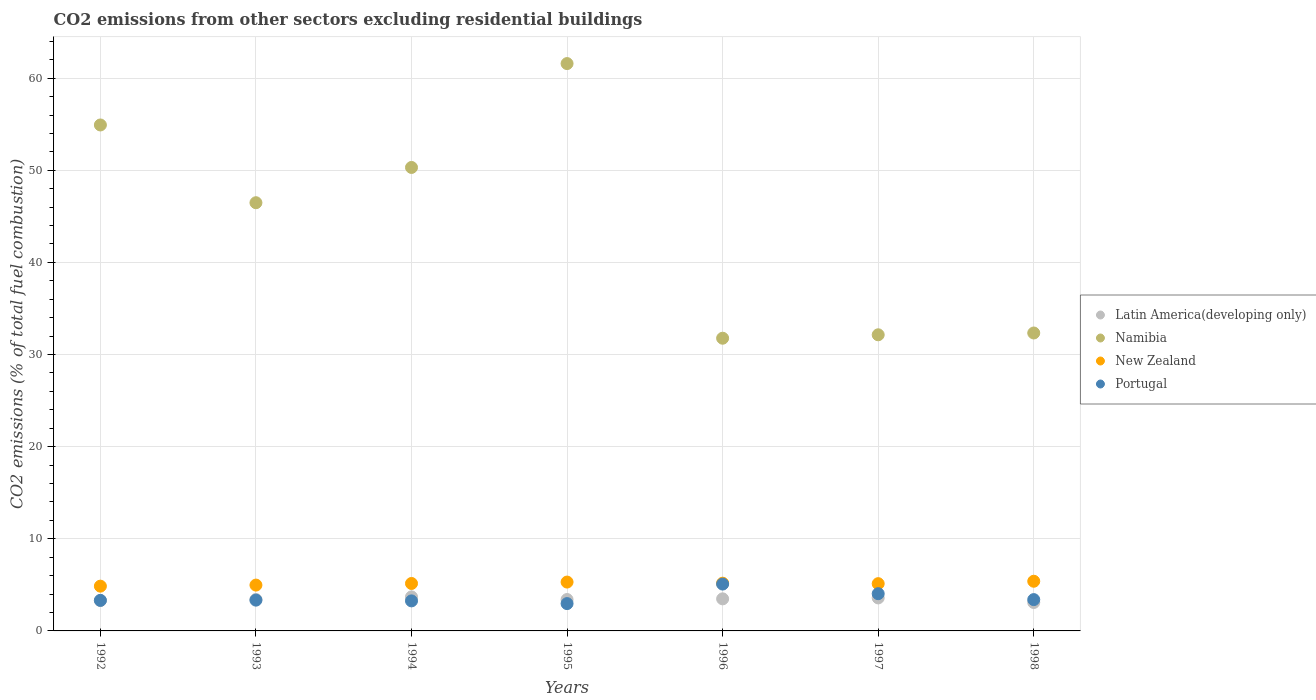Is the number of dotlines equal to the number of legend labels?
Provide a short and direct response. Yes. What is the total CO2 emitted in Portugal in 1998?
Your answer should be very brief. 3.4. Across all years, what is the maximum total CO2 emitted in New Zealand?
Make the answer very short. 5.39. Across all years, what is the minimum total CO2 emitted in Namibia?
Your response must be concise. 31.77. In which year was the total CO2 emitted in Latin America(developing only) maximum?
Offer a very short reply. 1994. What is the total total CO2 emitted in Latin America(developing only) in the graph?
Make the answer very short. 23.96. What is the difference between the total CO2 emitted in Namibia in 1997 and that in 1998?
Make the answer very short. -0.2. What is the difference between the total CO2 emitted in Namibia in 1997 and the total CO2 emitted in Portugal in 1996?
Keep it short and to the point. 27.06. What is the average total CO2 emitted in New Zealand per year?
Give a very brief answer. 5.14. In the year 1996, what is the difference between the total CO2 emitted in Portugal and total CO2 emitted in Namibia?
Make the answer very short. -26.68. What is the ratio of the total CO2 emitted in Latin America(developing only) in 1992 to that in 1998?
Your response must be concise. 1.07. Is the total CO2 emitted in Latin America(developing only) in 1995 less than that in 1998?
Give a very brief answer. No. What is the difference between the highest and the second highest total CO2 emitted in Portugal?
Your answer should be compact. 1.04. What is the difference between the highest and the lowest total CO2 emitted in Latin America(developing only)?
Offer a terse response. 0.61. Is the sum of the total CO2 emitted in Latin America(developing only) in 1993 and 1994 greater than the maximum total CO2 emitted in Namibia across all years?
Provide a short and direct response. No. Is it the case that in every year, the sum of the total CO2 emitted in Latin America(developing only) and total CO2 emitted in Namibia  is greater than the total CO2 emitted in Portugal?
Offer a very short reply. Yes. Is the total CO2 emitted in New Zealand strictly greater than the total CO2 emitted in Namibia over the years?
Provide a short and direct response. No. Is the total CO2 emitted in Latin America(developing only) strictly less than the total CO2 emitted in Namibia over the years?
Your answer should be compact. Yes. How many dotlines are there?
Your answer should be very brief. 4. What is the difference between two consecutive major ticks on the Y-axis?
Offer a terse response. 10. Does the graph contain any zero values?
Make the answer very short. No. What is the title of the graph?
Give a very brief answer. CO2 emissions from other sectors excluding residential buildings. Does "Albania" appear as one of the legend labels in the graph?
Provide a succinct answer. No. What is the label or title of the X-axis?
Offer a terse response. Years. What is the label or title of the Y-axis?
Your answer should be very brief. CO2 emissions (% of total fuel combustion). What is the CO2 emissions (% of total fuel combustion) in Latin America(developing only) in 1992?
Ensure brevity in your answer.  3.3. What is the CO2 emissions (% of total fuel combustion) of Namibia in 1992?
Ensure brevity in your answer.  54.92. What is the CO2 emissions (% of total fuel combustion) of New Zealand in 1992?
Make the answer very short. 4.86. What is the CO2 emissions (% of total fuel combustion) in Portugal in 1992?
Your answer should be very brief. 3.32. What is the CO2 emissions (% of total fuel combustion) in Latin America(developing only) in 1993?
Your response must be concise. 3.41. What is the CO2 emissions (% of total fuel combustion) in Namibia in 1993?
Give a very brief answer. 46.48. What is the CO2 emissions (% of total fuel combustion) in New Zealand in 1993?
Keep it short and to the point. 4.98. What is the CO2 emissions (% of total fuel combustion) in Portugal in 1993?
Make the answer very short. 3.34. What is the CO2 emissions (% of total fuel combustion) of Latin America(developing only) in 1994?
Your answer should be very brief. 3.69. What is the CO2 emissions (% of total fuel combustion) in Namibia in 1994?
Offer a very short reply. 50.31. What is the CO2 emissions (% of total fuel combustion) of New Zealand in 1994?
Provide a short and direct response. 5.15. What is the CO2 emissions (% of total fuel combustion) of Portugal in 1994?
Your response must be concise. 3.26. What is the CO2 emissions (% of total fuel combustion) in Latin America(developing only) in 1995?
Offer a very short reply. 3.41. What is the CO2 emissions (% of total fuel combustion) in Namibia in 1995?
Your answer should be compact. 61.58. What is the CO2 emissions (% of total fuel combustion) of New Zealand in 1995?
Offer a very short reply. 5.3. What is the CO2 emissions (% of total fuel combustion) of Portugal in 1995?
Your answer should be compact. 2.97. What is the CO2 emissions (% of total fuel combustion) in Latin America(developing only) in 1996?
Your answer should be very brief. 3.48. What is the CO2 emissions (% of total fuel combustion) in Namibia in 1996?
Offer a very short reply. 31.77. What is the CO2 emissions (% of total fuel combustion) in New Zealand in 1996?
Ensure brevity in your answer.  5.18. What is the CO2 emissions (% of total fuel combustion) of Portugal in 1996?
Your answer should be very brief. 5.09. What is the CO2 emissions (% of total fuel combustion) of Latin America(developing only) in 1997?
Offer a terse response. 3.58. What is the CO2 emissions (% of total fuel combustion) in Namibia in 1997?
Give a very brief answer. 32.14. What is the CO2 emissions (% of total fuel combustion) in New Zealand in 1997?
Provide a succinct answer. 5.13. What is the CO2 emissions (% of total fuel combustion) in Portugal in 1997?
Offer a very short reply. 4.04. What is the CO2 emissions (% of total fuel combustion) in Latin America(developing only) in 1998?
Provide a short and direct response. 3.09. What is the CO2 emissions (% of total fuel combustion) in Namibia in 1998?
Keep it short and to the point. 32.34. What is the CO2 emissions (% of total fuel combustion) of New Zealand in 1998?
Keep it short and to the point. 5.39. What is the CO2 emissions (% of total fuel combustion) in Portugal in 1998?
Your answer should be very brief. 3.4. Across all years, what is the maximum CO2 emissions (% of total fuel combustion) of Latin America(developing only)?
Ensure brevity in your answer.  3.69. Across all years, what is the maximum CO2 emissions (% of total fuel combustion) of Namibia?
Make the answer very short. 61.58. Across all years, what is the maximum CO2 emissions (% of total fuel combustion) of New Zealand?
Offer a very short reply. 5.39. Across all years, what is the maximum CO2 emissions (% of total fuel combustion) in Portugal?
Offer a very short reply. 5.09. Across all years, what is the minimum CO2 emissions (% of total fuel combustion) in Latin America(developing only)?
Your response must be concise. 3.09. Across all years, what is the minimum CO2 emissions (% of total fuel combustion) of Namibia?
Your answer should be compact. 31.77. Across all years, what is the minimum CO2 emissions (% of total fuel combustion) of New Zealand?
Keep it short and to the point. 4.86. Across all years, what is the minimum CO2 emissions (% of total fuel combustion) of Portugal?
Provide a succinct answer. 2.97. What is the total CO2 emissions (% of total fuel combustion) in Latin America(developing only) in the graph?
Ensure brevity in your answer.  23.96. What is the total CO2 emissions (% of total fuel combustion) in Namibia in the graph?
Offer a very short reply. 309.54. What is the total CO2 emissions (% of total fuel combustion) of New Zealand in the graph?
Ensure brevity in your answer.  35.99. What is the total CO2 emissions (% of total fuel combustion) of Portugal in the graph?
Your answer should be very brief. 25.41. What is the difference between the CO2 emissions (% of total fuel combustion) of Latin America(developing only) in 1992 and that in 1993?
Give a very brief answer. -0.11. What is the difference between the CO2 emissions (% of total fuel combustion) of Namibia in 1992 and that in 1993?
Your response must be concise. 8.44. What is the difference between the CO2 emissions (% of total fuel combustion) of New Zealand in 1992 and that in 1993?
Provide a succinct answer. -0.12. What is the difference between the CO2 emissions (% of total fuel combustion) of Portugal in 1992 and that in 1993?
Your response must be concise. -0.02. What is the difference between the CO2 emissions (% of total fuel combustion) of Latin America(developing only) in 1992 and that in 1994?
Give a very brief answer. -0.39. What is the difference between the CO2 emissions (% of total fuel combustion) of Namibia in 1992 and that in 1994?
Your answer should be compact. 4.61. What is the difference between the CO2 emissions (% of total fuel combustion) of New Zealand in 1992 and that in 1994?
Provide a succinct answer. -0.29. What is the difference between the CO2 emissions (% of total fuel combustion) in Portugal in 1992 and that in 1994?
Your answer should be very brief. 0.06. What is the difference between the CO2 emissions (% of total fuel combustion) of Latin America(developing only) in 1992 and that in 1995?
Make the answer very short. -0.11. What is the difference between the CO2 emissions (% of total fuel combustion) of Namibia in 1992 and that in 1995?
Offer a terse response. -6.66. What is the difference between the CO2 emissions (% of total fuel combustion) of New Zealand in 1992 and that in 1995?
Provide a succinct answer. -0.44. What is the difference between the CO2 emissions (% of total fuel combustion) in Portugal in 1992 and that in 1995?
Offer a terse response. 0.35. What is the difference between the CO2 emissions (% of total fuel combustion) of Latin America(developing only) in 1992 and that in 1996?
Your response must be concise. -0.18. What is the difference between the CO2 emissions (% of total fuel combustion) in Namibia in 1992 and that in 1996?
Give a very brief answer. 23.15. What is the difference between the CO2 emissions (% of total fuel combustion) of New Zealand in 1992 and that in 1996?
Offer a very short reply. -0.32. What is the difference between the CO2 emissions (% of total fuel combustion) of Portugal in 1992 and that in 1996?
Provide a short and direct response. -1.77. What is the difference between the CO2 emissions (% of total fuel combustion) of Latin America(developing only) in 1992 and that in 1997?
Keep it short and to the point. -0.28. What is the difference between the CO2 emissions (% of total fuel combustion) in Namibia in 1992 and that in 1997?
Give a very brief answer. 22.78. What is the difference between the CO2 emissions (% of total fuel combustion) of New Zealand in 1992 and that in 1997?
Provide a short and direct response. -0.27. What is the difference between the CO2 emissions (% of total fuel combustion) of Portugal in 1992 and that in 1997?
Keep it short and to the point. -0.73. What is the difference between the CO2 emissions (% of total fuel combustion) in Latin America(developing only) in 1992 and that in 1998?
Give a very brief answer. 0.21. What is the difference between the CO2 emissions (% of total fuel combustion) of Namibia in 1992 and that in 1998?
Offer a terse response. 22.58. What is the difference between the CO2 emissions (% of total fuel combustion) in New Zealand in 1992 and that in 1998?
Offer a very short reply. -0.53. What is the difference between the CO2 emissions (% of total fuel combustion) in Portugal in 1992 and that in 1998?
Your answer should be compact. -0.08. What is the difference between the CO2 emissions (% of total fuel combustion) of Latin America(developing only) in 1993 and that in 1994?
Your response must be concise. -0.28. What is the difference between the CO2 emissions (% of total fuel combustion) of Namibia in 1993 and that in 1994?
Offer a very short reply. -3.83. What is the difference between the CO2 emissions (% of total fuel combustion) in New Zealand in 1993 and that in 1994?
Provide a short and direct response. -0.17. What is the difference between the CO2 emissions (% of total fuel combustion) of Portugal in 1993 and that in 1994?
Your answer should be very brief. 0.08. What is the difference between the CO2 emissions (% of total fuel combustion) of Latin America(developing only) in 1993 and that in 1995?
Ensure brevity in your answer.  0. What is the difference between the CO2 emissions (% of total fuel combustion) in Namibia in 1993 and that in 1995?
Make the answer very short. -15.1. What is the difference between the CO2 emissions (% of total fuel combustion) of New Zealand in 1993 and that in 1995?
Your answer should be compact. -0.33. What is the difference between the CO2 emissions (% of total fuel combustion) in Portugal in 1993 and that in 1995?
Ensure brevity in your answer.  0.38. What is the difference between the CO2 emissions (% of total fuel combustion) of Latin America(developing only) in 1993 and that in 1996?
Ensure brevity in your answer.  -0.07. What is the difference between the CO2 emissions (% of total fuel combustion) of Namibia in 1993 and that in 1996?
Provide a short and direct response. 14.71. What is the difference between the CO2 emissions (% of total fuel combustion) of New Zealand in 1993 and that in 1996?
Give a very brief answer. -0.21. What is the difference between the CO2 emissions (% of total fuel combustion) of Portugal in 1993 and that in 1996?
Offer a terse response. -1.75. What is the difference between the CO2 emissions (% of total fuel combustion) in Latin America(developing only) in 1993 and that in 1997?
Your answer should be compact. -0.17. What is the difference between the CO2 emissions (% of total fuel combustion) in Namibia in 1993 and that in 1997?
Provide a succinct answer. 14.34. What is the difference between the CO2 emissions (% of total fuel combustion) in New Zealand in 1993 and that in 1997?
Keep it short and to the point. -0.15. What is the difference between the CO2 emissions (% of total fuel combustion) in Portugal in 1993 and that in 1997?
Provide a short and direct response. -0.7. What is the difference between the CO2 emissions (% of total fuel combustion) in Latin America(developing only) in 1993 and that in 1998?
Provide a succinct answer. 0.33. What is the difference between the CO2 emissions (% of total fuel combustion) in Namibia in 1993 and that in 1998?
Your answer should be compact. 14.14. What is the difference between the CO2 emissions (% of total fuel combustion) of New Zealand in 1993 and that in 1998?
Make the answer very short. -0.42. What is the difference between the CO2 emissions (% of total fuel combustion) of Portugal in 1993 and that in 1998?
Your answer should be very brief. -0.06. What is the difference between the CO2 emissions (% of total fuel combustion) in Latin America(developing only) in 1994 and that in 1995?
Provide a succinct answer. 0.28. What is the difference between the CO2 emissions (% of total fuel combustion) of Namibia in 1994 and that in 1995?
Provide a succinct answer. -11.28. What is the difference between the CO2 emissions (% of total fuel combustion) of New Zealand in 1994 and that in 1995?
Keep it short and to the point. -0.15. What is the difference between the CO2 emissions (% of total fuel combustion) in Portugal in 1994 and that in 1995?
Your response must be concise. 0.29. What is the difference between the CO2 emissions (% of total fuel combustion) in Latin America(developing only) in 1994 and that in 1996?
Offer a very short reply. 0.21. What is the difference between the CO2 emissions (% of total fuel combustion) of Namibia in 1994 and that in 1996?
Provide a succinct answer. 18.54. What is the difference between the CO2 emissions (% of total fuel combustion) of New Zealand in 1994 and that in 1996?
Your response must be concise. -0.03. What is the difference between the CO2 emissions (% of total fuel combustion) in Portugal in 1994 and that in 1996?
Keep it short and to the point. -1.83. What is the difference between the CO2 emissions (% of total fuel combustion) in Latin America(developing only) in 1994 and that in 1997?
Offer a very short reply. 0.11. What is the difference between the CO2 emissions (% of total fuel combustion) in Namibia in 1994 and that in 1997?
Your response must be concise. 18.16. What is the difference between the CO2 emissions (% of total fuel combustion) in New Zealand in 1994 and that in 1997?
Your answer should be very brief. 0.02. What is the difference between the CO2 emissions (% of total fuel combustion) in Portugal in 1994 and that in 1997?
Give a very brief answer. -0.78. What is the difference between the CO2 emissions (% of total fuel combustion) in Latin America(developing only) in 1994 and that in 1998?
Keep it short and to the point. 0.61. What is the difference between the CO2 emissions (% of total fuel combustion) of Namibia in 1994 and that in 1998?
Make the answer very short. 17.97. What is the difference between the CO2 emissions (% of total fuel combustion) in New Zealand in 1994 and that in 1998?
Provide a short and direct response. -0.24. What is the difference between the CO2 emissions (% of total fuel combustion) of Portugal in 1994 and that in 1998?
Your answer should be very brief. -0.14. What is the difference between the CO2 emissions (% of total fuel combustion) of Latin America(developing only) in 1995 and that in 1996?
Give a very brief answer. -0.07. What is the difference between the CO2 emissions (% of total fuel combustion) of Namibia in 1995 and that in 1996?
Offer a very short reply. 29.81. What is the difference between the CO2 emissions (% of total fuel combustion) of New Zealand in 1995 and that in 1996?
Your answer should be compact. 0.12. What is the difference between the CO2 emissions (% of total fuel combustion) of Portugal in 1995 and that in 1996?
Provide a succinct answer. -2.12. What is the difference between the CO2 emissions (% of total fuel combustion) of Latin America(developing only) in 1995 and that in 1997?
Offer a terse response. -0.17. What is the difference between the CO2 emissions (% of total fuel combustion) of Namibia in 1995 and that in 1997?
Your answer should be compact. 29.44. What is the difference between the CO2 emissions (% of total fuel combustion) of New Zealand in 1995 and that in 1997?
Give a very brief answer. 0.17. What is the difference between the CO2 emissions (% of total fuel combustion) of Portugal in 1995 and that in 1997?
Provide a short and direct response. -1.08. What is the difference between the CO2 emissions (% of total fuel combustion) in Latin America(developing only) in 1995 and that in 1998?
Provide a succinct answer. 0.32. What is the difference between the CO2 emissions (% of total fuel combustion) in Namibia in 1995 and that in 1998?
Ensure brevity in your answer.  29.24. What is the difference between the CO2 emissions (% of total fuel combustion) of New Zealand in 1995 and that in 1998?
Offer a very short reply. -0.09. What is the difference between the CO2 emissions (% of total fuel combustion) of Portugal in 1995 and that in 1998?
Your answer should be very brief. -0.43. What is the difference between the CO2 emissions (% of total fuel combustion) in Latin America(developing only) in 1996 and that in 1997?
Provide a succinct answer. -0.1. What is the difference between the CO2 emissions (% of total fuel combustion) of Namibia in 1996 and that in 1997?
Provide a succinct answer. -0.37. What is the difference between the CO2 emissions (% of total fuel combustion) of New Zealand in 1996 and that in 1997?
Your answer should be compact. 0.05. What is the difference between the CO2 emissions (% of total fuel combustion) of Portugal in 1996 and that in 1997?
Your answer should be very brief. 1.04. What is the difference between the CO2 emissions (% of total fuel combustion) in Latin America(developing only) in 1996 and that in 1998?
Offer a very short reply. 0.4. What is the difference between the CO2 emissions (% of total fuel combustion) in Namibia in 1996 and that in 1998?
Your response must be concise. -0.57. What is the difference between the CO2 emissions (% of total fuel combustion) of New Zealand in 1996 and that in 1998?
Give a very brief answer. -0.21. What is the difference between the CO2 emissions (% of total fuel combustion) in Portugal in 1996 and that in 1998?
Give a very brief answer. 1.69. What is the difference between the CO2 emissions (% of total fuel combustion) in Latin America(developing only) in 1997 and that in 1998?
Your response must be concise. 0.5. What is the difference between the CO2 emissions (% of total fuel combustion) in Namibia in 1997 and that in 1998?
Provide a short and direct response. -0.2. What is the difference between the CO2 emissions (% of total fuel combustion) of New Zealand in 1997 and that in 1998?
Offer a very short reply. -0.26. What is the difference between the CO2 emissions (% of total fuel combustion) of Portugal in 1997 and that in 1998?
Your response must be concise. 0.64. What is the difference between the CO2 emissions (% of total fuel combustion) of Latin America(developing only) in 1992 and the CO2 emissions (% of total fuel combustion) of Namibia in 1993?
Offer a terse response. -43.18. What is the difference between the CO2 emissions (% of total fuel combustion) of Latin America(developing only) in 1992 and the CO2 emissions (% of total fuel combustion) of New Zealand in 1993?
Provide a short and direct response. -1.68. What is the difference between the CO2 emissions (% of total fuel combustion) of Latin America(developing only) in 1992 and the CO2 emissions (% of total fuel combustion) of Portugal in 1993?
Ensure brevity in your answer.  -0.04. What is the difference between the CO2 emissions (% of total fuel combustion) of Namibia in 1992 and the CO2 emissions (% of total fuel combustion) of New Zealand in 1993?
Your answer should be compact. 49.94. What is the difference between the CO2 emissions (% of total fuel combustion) in Namibia in 1992 and the CO2 emissions (% of total fuel combustion) in Portugal in 1993?
Your answer should be very brief. 51.58. What is the difference between the CO2 emissions (% of total fuel combustion) of New Zealand in 1992 and the CO2 emissions (% of total fuel combustion) of Portugal in 1993?
Make the answer very short. 1.52. What is the difference between the CO2 emissions (% of total fuel combustion) in Latin America(developing only) in 1992 and the CO2 emissions (% of total fuel combustion) in Namibia in 1994?
Offer a terse response. -47.01. What is the difference between the CO2 emissions (% of total fuel combustion) of Latin America(developing only) in 1992 and the CO2 emissions (% of total fuel combustion) of New Zealand in 1994?
Ensure brevity in your answer.  -1.85. What is the difference between the CO2 emissions (% of total fuel combustion) in Latin America(developing only) in 1992 and the CO2 emissions (% of total fuel combustion) in Portugal in 1994?
Provide a short and direct response. 0.04. What is the difference between the CO2 emissions (% of total fuel combustion) in Namibia in 1992 and the CO2 emissions (% of total fuel combustion) in New Zealand in 1994?
Provide a short and direct response. 49.77. What is the difference between the CO2 emissions (% of total fuel combustion) in Namibia in 1992 and the CO2 emissions (% of total fuel combustion) in Portugal in 1994?
Provide a succinct answer. 51.66. What is the difference between the CO2 emissions (% of total fuel combustion) of New Zealand in 1992 and the CO2 emissions (% of total fuel combustion) of Portugal in 1994?
Offer a terse response. 1.6. What is the difference between the CO2 emissions (% of total fuel combustion) of Latin America(developing only) in 1992 and the CO2 emissions (% of total fuel combustion) of Namibia in 1995?
Give a very brief answer. -58.28. What is the difference between the CO2 emissions (% of total fuel combustion) in Latin America(developing only) in 1992 and the CO2 emissions (% of total fuel combustion) in New Zealand in 1995?
Give a very brief answer. -2. What is the difference between the CO2 emissions (% of total fuel combustion) in Latin America(developing only) in 1992 and the CO2 emissions (% of total fuel combustion) in Portugal in 1995?
Provide a succinct answer. 0.33. What is the difference between the CO2 emissions (% of total fuel combustion) in Namibia in 1992 and the CO2 emissions (% of total fuel combustion) in New Zealand in 1995?
Ensure brevity in your answer.  49.62. What is the difference between the CO2 emissions (% of total fuel combustion) of Namibia in 1992 and the CO2 emissions (% of total fuel combustion) of Portugal in 1995?
Your answer should be compact. 51.95. What is the difference between the CO2 emissions (% of total fuel combustion) in New Zealand in 1992 and the CO2 emissions (% of total fuel combustion) in Portugal in 1995?
Your answer should be very brief. 1.89. What is the difference between the CO2 emissions (% of total fuel combustion) of Latin America(developing only) in 1992 and the CO2 emissions (% of total fuel combustion) of Namibia in 1996?
Provide a succinct answer. -28.47. What is the difference between the CO2 emissions (% of total fuel combustion) of Latin America(developing only) in 1992 and the CO2 emissions (% of total fuel combustion) of New Zealand in 1996?
Offer a very short reply. -1.88. What is the difference between the CO2 emissions (% of total fuel combustion) of Latin America(developing only) in 1992 and the CO2 emissions (% of total fuel combustion) of Portugal in 1996?
Offer a terse response. -1.79. What is the difference between the CO2 emissions (% of total fuel combustion) of Namibia in 1992 and the CO2 emissions (% of total fuel combustion) of New Zealand in 1996?
Give a very brief answer. 49.74. What is the difference between the CO2 emissions (% of total fuel combustion) in Namibia in 1992 and the CO2 emissions (% of total fuel combustion) in Portugal in 1996?
Ensure brevity in your answer.  49.83. What is the difference between the CO2 emissions (% of total fuel combustion) in New Zealand in 1992 and the CO2 emissions (% of total fuel combustion) in Portugal in 1996?
Provide a short and direct response. -0.23. What is the difference between the CO2 emissions (% of total fuel combustion) of Latin America(developing only) in 1992 and the CO2 emissions (% of total fuel combustion) of Namibia in 1997?
Offer a terse response. -28.84. What is the difference between the CO2 emissions (% of total fuel combustion) of Latin America(developing only) in 1992 and the CO2 emissions (% of total fuel combustion) of New Zealand in 1997?
Your answer should be very brief. -1.83. What is the difference between the CO2 emissions (% of total fuel combustion) in Latin America(developing only) in 1992 and the CO2 emissions (% of total fuel combustion) in Portugal in 1997?
Offer a terse response. -0.74. What is the difference between the CO2 emissions (% of total fuel combustion) in Namibia in 1992 and the CO2 emissions (% of total fuel combustion) in New Zealand in 1997?
Ensure brevity in your answer.  49.79. What is the difference between the CO2 emissions (% of total fuel combustion) in Namibia in 1992 and the CO2 emissions (% of total fuel combustion) in Portugal in 1997?
Keep it short and to the point. 50.88. What is the difference between the CO2 emissions (% of total fuel combustion) in New Zealand in 1992 and the CO2 emissions (% of total fuel combustion) in Portugal in 1997?
Your answer should be compact. 0.82. What is the difference between the CO2 emissions (% of total fuel combustion) of Latin America(developing only) in 1992 and the CO2 emissions (% of total fuel combustion) of Namibia in 1998?
Provide a succinct answer. -29.04. What is the difference between the CO2 emissions (% of total fuel combustion) in Latin America(developing only) in 1992 and the CO2 emissions (% of total fuel combustion) in New Zealand in 1998?
Make the answer very short. -2.09. What is the difference between the CO2 emissions (% of total fuel combustion) in Latin America(developing only) in 1992 and the CO2 emissions (% of total fuel combustion) in Portugal in 1998?
Ensure brevity in your answer.  -0.1. What is the difference between the CO2 emissions (% of total fuel combustion) in Namibia in 1992 and the CO2 emissions (% of total fuel combustion) in New Zealand in 1998?
Make the answer very short. 49.53. What is the difference between the CO2 emissions (% of total fuel combustion) in Namibia in 1992 and the CO2 emissions (% of total fuel combustion) in Portugal in 1998?
Ensure brevity in your answer.  51.52. What is the difference between the CO2 emissions (% of total fuel combustion) of New Zealand in 1992 and the CO2 emissions (% of total fuel combustion) of Portugal in 1998?
Offer a very short reply. 1.46. What is the difference between the CO2 emissions (% of total fuel combustion) of Latin America(developing only) in 1993 and the CO2 emissions (% of total fuel combustion) of Namibia in 1994?
Offer a terse response. -46.89. What is the difference between the CO2 emissions (% of total fuel combustion) of Latin America(developing only) in 1993 and the CO2 emissions (% of total fuel combustion) of New Zealand in 1994?
Give a very brief answer. -1.74. What is the difference between the CO2 emissions (% of total fuel combustion) of Latin America(developing only) in 1993 and the CO2 emissions (% of total fuel combustion) of Portugal in 1994?
Keep it short and to the point. 0.15. What is the difference between the CO2 emissions (% of total fuel combustion) in Namibia in 1993 and the CO2 emissions (% of total fuel combustion) in New Zealand in 1994?
Your answer should be compact. 41.33. What is the difference between the CO2 emissions (% of total fuel combustion) of Namibia in 1993 and the CO2 emissions (% of total fuel combustion) of Portugal in 1994?
Your answer should be compact. 43.22. What is the difference between the CO2 emissions (% of total fuel combustion) of New Zealand in 1993 and the CO2 emissions (% of total fuel combustion) of Portugal in 1994?
Offer a very short reply. 1.72. What is the difference between the CO2 emissions (% of total fuel combustion) of Latin America(developing only) in 1993 and the CO2 emissions (% of total fuel combustion) of Namibia in 1995?
Your answer should be compact. -58.17. What is the difference between the CO2 emissions (% of total fuel combustion) in Latin America(developing only) in 1993 and the CO2 emissions (% of total fuel combustion) in New Zealand in 1995?
Your answer should be compact. -1.89. What is the difference between the CO2 emissions (% of total fuel combustion) in Latin America(developing only) in 1993 and the CO2 emissions (% of total fuel combustion) in Portugal in 1995?
Offer a terse response. 0.45. What is the difference between the CO2 emissions (% of total fuel combustion) of Namibia in 1993 and the CO2 emissions (% of total fuel combustion) of New Zealand in 1995?
Your answer should be compact. 41.18. What is the difference between the CO2 emissions (% of total fuel combustion) of Namibia in 1993 and the CO2 emissions (% of total fuel combustion) of Portugal in 1995?
Your answer should be very brief. 43.51. What is the difference between the CO2 emissions (% of total fuel combustion) in New Zealand in 1993 and the CO2 emissions (% of total fuel combustion) in Portugal in 1995?
Your response must be concise. 2.01. What is the difference between the CO2 emissions (% of total fuel combustion) in Latin America(developing only) in 1993 and the CO2 emissions (% of total fuel combustion) in Namibia in 1996?
Make the answer very short. -28.36. What is the difference between the CO2 emissions (% of total fuel combustion) in Latin America(developing only) in 1993 and the CO2 emissions (% of total fuel combustion) in New Zealand in 1996?
Keep it short and to the point. -1.77. What is the difference between the CO2 emissions (% of total fuel combustion) of Latin America(developing only) in 1993 and the CO2 emissions (% of total fuel combustion) of Portugal in 1996?
Offer a terse response. -1.67. What is the difference between the CO2 emissions (% of total fuel combustion) in Namibia in 1993 and the CO2 emissions (% of total fuel combustion) in New Zealand in 1996?
Keep it short and to the point. 41.3. What is the difference between the CO2 emissions (% of total fuel combustion) of Namibia in 1993 and the CO2 emissions (% of total fuel combustion) of Portugal in 1996?
Make the answer very short. 41.39. What is the difference between the CO2 emissions (% of total fuel combustion) in New Zealand in 1993 and the CO2 emissions (% of total fuel combustion) in Portugal in 1996?
Your answer should be very brief. -0.11. What is the difference between the CO2 emissions (% of total fuel combustion) in Latin America(developing only) in 1993 and the CO2 emissions (% of total fuel combustion) in Namibia in 1997?
Provide a succinct answer. -28.73. What is the difference between the CO2 emissions (% of total fuel combustion) in Latin America(developing only) in 1993 and the CO2 emissions (% of total fuel combustion) in New Zealand in 1997?
Offer a terse response. -1.72. What is the difference between the CO2 emissions (% of total fuel combustion) in Latin America(developing only) in 1993 and the CO2 emissions (% of total fuel combustion) in Portugal in 1997?
Your answer should be very brief. -0.63. What is the difference between the CO2 emissions (% of total fuel combustion) in Namibia in 1993 and the CO2 emissions (% of total fuel combustion) in New Zealand in 1997?
Your response must be concise. 41.35. What is the difference between the CO2 emissions (% of total fuel combustion) of Namibia in 1993 and the CO2 emissions (% of total fuel combustion) of Portugal in 1997?
Offer a very short reply. 42.44. What is the difference between the CO2 emissions (% of total fuel combustion) of New Zealand in 1993 and the CO2 emissions (% of total fuel combustion) of Portugal in 1997?
Offer a terse response. 0.93. What is the difference between the CO2 emissions (% of total fuel combustion) in Latin America(developing only) in 1993 and the CO2 emissions (% of total fuel combustion) in Namibia in 1998?
Your answer should be compact. -28.93. What is the difference between the CO2 emissions (% of total fuel combustion) in Latin America(developing only) in 1993 and the CO2 emissions (% of total fuel combustion) in New Zealand in 1998?
Keep it short and to the point. -1.98. What is the difference between the CO2 emissions (% of total fuel combustion) of Latin America(developing only) in 1993 and the CO2 emissions (% of total fuel combustion) of Portugal in 1998?
Provide a short and direct response. 0.01. What is the difference between the CO2 emissions (% of total fuel combustion) in Namibia in 1993 and the CO2 emissions (% of total fuel combustion) in New Zealand in 1998?
Ensure brevity in your answer.  41.09. What is the difference between the CO2 emissions (% of total fuel combustion) in Namibia in 1993 and the CO2 emissions (% of total fuel combustion) in Portugal in 1998?
Offer a terse response. 43.08. What is the difference between the CO2 emissions (% of total fuel combustion) in New Zealand in 1993 and the CO2 emissions (% of total fuel combustion) in Portugal in 1998?
Make the answer very short. 1.58. What is the difference between the CO2 emissions (% of total fuel combustion) in Latin America(developing only) in 1994 and the CO2 emissions (% of total fuel combustion) in Namibia in 1995?
Ensure brevity in your answer.  -57.89. What is the difference between the CO2 emissions (% of total fuel combustion) in Latin America(developing only) in 1994 and the CO2 emissions (% of total fuel combustion) in New Zealand in 1995?
Give a very brief answer. -1.61. What is the difference between the CO2 emissions (% of total fuel combustion) in Latin America(developing only) in 1994 and the CO2 emissions (% of total fuel combustion) in Portugal in 1995?
Make the answer very short. 0.73. What is the difference between the CO2 emissions (% of total fuel combustion) of Namibia in 1994 and the CO2 emissions (% of total fuel combustion) of New Zealand in 1995?
Provide a succinct answer. 45. What is the difference between the CO2 emissions (% of total fuel combustion) in Namibia in 1994 and the CO2 emissions (% of total fuel combustion) in Portugal in 1995?
Provide a short and direct response. 47.34. What is the difference between the CO2 emissions (% of total fuel combustion) of New Zealand in 1994 and the CO2 emissions (% of total fuel combustion) of Portugal in 1995?
Make the answer very short. 2.18. What is the difference between the CO2 emissions (% of total fuel combustion) in Latin America(developing only) in 1994 and the CO2 emissions (% of total fuel combustion) in Namibia in 1996?
Offer a very short reply. -28.08. What is the difference between the CO2 emissions (% of total fuel combustion) of Latin America(developing only) in 1994 and the CO2 emissions (% of total fuel combustion) of New Zealand in 1996?
Give a very brief answer. -1.49. What is the difference between the CO2 emissions (% of total fuel combustion) in Latin America(developing only) in 1994 and the CO2 emissions (% of total fuel combustion) in Portugal in 1996?
Give a very brief answer. -1.39. What is the difference between the CO2 emissions (% of total fuel combustion) in Namibia in 1994 and the CO2 emissions (% of total fuel combustion) in New Zealand in 1996?
Your response must be concise. 45.13. What is the difference between the CO2 emissions (% of total fuel combustion) in Namibia in 1994 and the CO2 emissions (% of total fuel combustion) in Portugal in 1996?
Your answer should be compact. 45.22. What is the difference between the CO2 emissions (% of total fuel combustion) in New Zealand in 1994 and the CO2 emissions (% of total fuel combustion) in Portugal in 1996?
Offer a terse response. 0.06. What is the difference between the CO2 emissions (% of total fuel combustion) in Latin America(developing only) in 1994 and the CO2 emissions (% of total fuel combustion) in Namibia in 1997?
Ensure brevity in your answer.  -28.45. What is the difference between the CO2 emissions (% of total fuel combustion) of Latin America(developing only) in 1994 and the CO2 emissions (% of total fuel combustion) of New Zealand in 1997?
Ensure brevity in your answer.  -1.44. What is the difference between the CO2 emissions (% of total fuel combustion) in Latin America(developing only) in 1994 and the CO2 emissions (% of total fuel combustion) in Portugal in 1997?
Your answer should be very brief. -0.35. What is the difference between the CO2 emissions (% of total fuel combustion) of Namibia in 1994 and the CO2 emissions (% of total fuel combustion) of New Zealand in 1997?
Make the answer very short. 45.18. What is the difference between the CO2 emissions (% of total fuel combustion) of Namibia in 1994 and the CO2 emissions (% of total fuel combustion) of Portugal in 1997?
Make the answer very short. 46.26. What is the difference between the CO2 emissions (% of total fuel combustion) in New Zealand in 1994 and the CO2 emissions (% of total fuel combustion) in Portugal in 1997?
Provide a succinct answer. 1.11. What is the difference between the CO2 emissions (% of total fuel combustion) of Latin America(developing only) in 1994 and the CO2 emissions (% of total fuel combustion) of Namibia in 1998?
Offer a very short reply. -28.65. What is the difference between the CO2 emissions (% of total fuel combustion) in Latin America(developing only) in 1994 and the CO2 emissions (% of total fuel combustion) in New Zealand in 1998?
Provide a succinct answer. -1.7. What is the difference between the CO2 emissions (% of total fuel combustion) of Latin America(developing only) in 1994 and the CO2 emissions (% of total fuel combustion) of Portugal in 1998?
Keep it short and to the point. 0.29. What is the difference between the CO2 emissions (% of total fuel combustion) of Namibia in 1994 and the CO2 emissions (% of total fuel combustion) of New Zealand in 1998?
Your response must be concise. 44.91. What is the difference between the CO2 emissions (% of total fuel combustion) of Namibia in 1994 and the CO2 emissions (% of total fuel combustion) of Portugal in 1998?
Your answer should be compact. 46.91. What is the difference between the CO2 emissions (% of total fuel combustion) of New Zealand in 1994 and the CO2 emissions (% of total fuel combustion) of Portugal in 1998?
Provide a succinct answer. 1.75. What is the difference between the CO2 emissions (% of total fuel combustion) in Latin America(developing only) in 1995 and the CO2 emissions (% of total fuel combustion) in Namibia in 1996?
Your response must be concise. -28.36. What is the difference between the CO2 emissions (% of total fuel combustion) in Latin America(developing only) in 1995 and the CO2 emissions (% of total fuel combustion) in New Zealand in 1996?
Your response must be concise. -1.77. What is the difference between the CO2 emissions (% of total fuel combustion) in Latin America(developing only) in 1995 and the CO2 emissions (% of total fuel combustion) in Portugal in 1996?
Your response must be concise. -1.68. What is the difference between the CO2 emissions (% of total fuel combustion) in Namibia in 1995 and the CO2 emissions (% of total fuel combustion) in New Zealand in 1996?
Keep it short and to the point. 56.4. What is the difference between the CO2 emissions (% of total fuel combustion) of Namibia in 1995 and the CO2 emissions (% of total fuel combustion) of Portugal in 1996?
Offer a terse response. 56.5. What is the difference between the CO2 emissions (% of total fuel combustion) in New Zealand in 1995 and the CO2 emissions (% of total fuel combustion) in Portugal in 1996?
Your answer should be very brief. 0.22. What is the difference between the CO2 emissions (% of total fuel combustion) in Latin America(developing only) in 1995 and the CO2 emissions (% of total fuel combustion) in Namibia in 1997?
Offer a terse response. -28.73. What is the difference between the CO2 emissions (% of total fuel combustion) of Latin America(developing only) in 1995 and the CO2 emissions (% of total fuel combustion) of New Zealand in 1997?
Keep it short and to the point. -1.72. What is the difference between the CO2 emissions (% of total fuel combustion) of Latin America(developing only) in 1995 and the CO2 emissions (% of total fuel combustion) of Portugal in 1997?
Your response must be concise. -0.63. What is the difference between the CO2 emissions (% of total fuel combustion) in Namibia in 1995 and the CO2 emissions (% of total fuel combustion) in New Zealand in 1997?
Your answer should be compact. 56.45. What is the difference between the CO2 emissions (% of total fuel combustion) of Namibia in 1995 and the CO2 emissions (% of total fuel combustion) of Portugal in 1997?
Give a very brief answer. 57.54. What is the difference between the CO2 emissions (% of total fuel combustion) in New Zealand in 1995 and the CO2 emissions (% of total fuel combustion) in Portugal in 1997?
Your answer should be very brief. 1.26. What is the difference between the CO2 emissions (% of total fuel combustion) of Latin America(developing only) in 1995 and the CO2 emissions (% of total fuel combustion) of Namibia in 1998?
Your answer should be compact. -28.93. What is the difference between the CO2 emissions (% of total fuel combustion) of Latin America(developing only) in 1995 and the CO2 emissions (% of total fuel combustion) of New Zealand in 1998?
Ensure brevity in your answer.  -1.98. What is the difference between the CO2 emissions (% of total fuel combustion) in Latin America(developing only) in 1995 and the CO2 emissions (% of total fuel combustion) in Portugal in 1998?
Make the answer very short. 0.01. What is the difference between the CO2 emissions (% of total fuel combustion) of Namibia in 1995 and the CO2 emissions (% of total fuel combustion) of New Zealand in 1998?
Keep it short and to the point. 56.19. What is the difference between the CO2 emissions (% of total fuel combustion) in Namibia in 1995 and the CO2 emissions (% of total fuel combustion) in Portugal in 1998?
Make the answer very short. 58.18. What is the difference between the CO2 emissions (% of total fuel combustion) of New Zealand in 1995 and the CO2 emissions (% of total fuel combustion) of Portugal in 1998?
Ensure brevity in your answer.  1.9. What is the difference between the CO2 emissions (% of total fuel combustion) in Latin America(developing only) in 1996 and the CO2 emissions (% of total fuel combustion) in Namibia in 1997?
Your answer should be very brief. -28.66. What is the difference between the CO2 emissions (% of total fuel combustion) of Latin America(developing only) in 1996 and the CO2 emissions (% of total fuel combustion) of New Zealand in 1997?
Ensure brevity in your answer.  -1.65. What is the difference between the CO2 emissions (% of total fuel combustion) of Latin America(developing only) in 1996 and the CO2 emissions (% of total fuel combustion) of Portugal in 1997?
Offer a terse response. -0.56. What is the difference between the CO2 emissions (% of total fuel combustion) of Namibia in 1996 and the CO2 emissions (% of total fuel combustion) of New Zealand in 1997?
Offer a very short reply. 26.64. What is the difference between the CO2 emissions (% of total fuel combustion) of Namibia in 1996 and the CO2 emissions (% of total fuel combustion) of Portugal in 1997?
Ensure brevity in your answer.  27.73. What is the difference between the CO2 emissions (% of total fuel combustion) of New Zealand in 1996 and the CO2 emissions (% of total fuel combustion) of Portugal in 1997?
Your answer should be compact. 1.14. What is the difference between the CO2 emissions (% of total fuel combustion) in Latin America(developing only) in 1996 and the CO2 emissions (% of total fuel combustion) in Namibia in 1998?
Offer a very short reply. -28.86. What is the difference between the CO2 emissions (% of total fuel combustion) in Latin America(developing only) in 1996 and the CO2 emissions (% of total fuel combustion) in New Zealand in 1998?
Offer a very short reply. -1.91. What is the difference between the CO2 emissions (% of total fuel combustion) of Latin America(developing only) in 1996 and the CO2 emissions (% of total fuel combustion) of Portugal in 1998?
Make the answer very short. 0.08. What is the difference between the CO2 emissions (% of total fuel combustion) in Namibia in 1996 and the CO2 emissions (% of total fuel combustion) in New Zealand in 1998?
Keep it short and to the point. 26.38. What is the difference between the CO2 emissions (% of total fuel combustion) in Namibia in 1996 and the CO2 emissions (% of total fuel combustion) in Portugal in 1998?
Ensure brevity in your answer.  28.37. What is the difference between the CO2 emissions (% of total fuel combustion) in New Zealand in 1996 and the CO2 emissions (% of total fuel combustion) in Portugal in 1998?
Provide a short and direct response. 1.78. What is the difference between the CO2 emissions (% of total fuel combustion) in Latin America(developing only) in 1997 and the CO2 emissions (% of total fuel combustion) in Namibia in 1998?
Your response must be concise. -28.76. What is the difference between the CO2 emissions (% of total fuel combustion) of Latin America(developing only) in 1997 and the CO2 emissions (% of total fuel combustion) of New Zealand in 1998?
Keep it short and to the point. -1.81. What is the difference between the CO2 emissions (% of total fuel combustion) of Latin America(developing only) in 1997 and the CO2 emissions (% of total fuel combustion) of Portugal in 1998?
Give a very brief answer. 0.18. What is the difference between the CO2 emissions (% of total fuel combustion) in Namibia in 1997 and the CO2 emissions (% of total fuel combustion) in New Zealand in 1998?
Ensure brevity in your answer.  26.75. What is the difference between the CO2 emissions (% of total fuel combustion) of Namibia in 1997 and the CO2 emissions (% of total fuel combustion) of Portugal in 1998?
Your answer should be compact. 28.74. What is the difference between the CO2 emissions (% of total fuel combustion) in New Zealand in 1997 and the CO2 emissions (% of total fuel combustion) in Portugal in 1998?
Offer a very short reply. 1.73. What is the average CO2 emissions (% of total fuel combustion) in Latin America(developing only) per year?
Keep it short and to the point. 3.42. What is the average CO2 emissions (% of total fuel combustion) of Namibia per year?
Give a very brief answer. 44.22. What is the average CO2 emissions (% of total fuel combustion) of New Zealand per year?
Offer a terse response. 5.14. What is the average CO2 emissions (% of total fuel combustion) of Portugal per year?
Give a very brief answer. 3.63. In the year 1992, what is the difference between the CO2 emissions (% of total fuel combustion) in Latin America(developing only) and CO2 emissions (% of total fuel combustion) in Namibia?
Keep it short and to the point. -51.62. In the year 1992, what is the difference between the CO2 emissions (% of total fuel combustion) in Latin America(developing only) and CO2 emissions (% of total fuel combustion) in New Zealand?
Offer a very short reply. -1.56. In the year 1992, what is the difference between the CO2 emissions (% of total fuel combustion) in Latin America(developing only) and CO2 emissions (% of total fuel combustion) in Portugal?
Give a very brief answer. -0.02. In the year 1992, what is the difference between the CO2 emissions (% of total fuel combustion) of Namibia and CO2 emissions (% of total fuel combustion) of New Zealand?
Keep it short and to the point. 50.06. In the year 1992, what is the difference between the CO2 emissions (% of total fuel combustion) in Namibia and CO2 emissions (% of total fuel combustion) in Portugal?
Offer a terse response. 51.6. In the year 1992, what is the difference between the CO2 emissions (% of total fuel combustion) in New Zealand and CO2 emissions (% of total fuel combustion) in Portugal?
Your answer should be compact. 1.54. In the year 1993, what is the difference between the CO2 emissions (% of total fuel combustion) in Latin America(developing only) and CO2 emissions (% of total fuel combustion) in Namibia?
Your answer should be very brief. -43.07. In the year 1993, what is the difference between the CO2 emissions (% of total fuel combustion) of Latin America(developing only) and CO2 emissions (% of total fuel combustion) of New Zealand?
Keep it short and to the point. -1.56. In the year 1993, what is the difference between the CO2 emissions (% of total fuel combustion) of Latin America(developing only) and CO2 emissions (% of total fuel combustion) of Portugal?
Keep it short and to the point. 0.07. In the year 1993, what is the difference between the CO2 emissions (% of total fuel combustion) of Namibia and CO2 emissions (% of total fuel combustion) of New Zealand?
Keep it short and to the point. 41.5. In the year 1993, what is the difference between the CO2 emissions (% of total fuel combustion) in Namibia and CO2 emissions (% of total fuel combustion) in Portugal?
Your answer should be very brief. 43.14. In the year 1993, what is the difference between the CO2 emissions (% of total fuel combustion) in New Zealand and CO2 emissions (% of total fuel combustion) in Portugal?
Keep it short and to the point. 1.63. In the year 1994, what is the difference between the CO2 emissions (% of total fuel combustion) of Latin America(developing only) and CO2 emissions (% of total fuel combustion) of Namibia?
Offer a very short reply. -46.61. In the year 1994, what is the difference between the CO2 emissions (% of total fuel combustion) in Latin America(developing only) and CO2 emissions (% of total fuel combustion) in New Zealand?
Make the answer very short. -1.46. In the year 1994, what is the difference between the CO2 emissions (% of total fuel combustion) in Latin America(developing only) and CO2 emissions (% of total fuel combustion) in Portugal?
Your response must be concise. 0.43. In the year 1994, what is the difference between the CO2 emissions (% of total fuel combustion) of Namibia and CO2 emissions (% of total fuel combustion) of New Zealand?
Keep it short and to the point. 45.16. In the year 1994, what is the difference between the CO2 emissions (% of total fuel combustion) in Namibia and CO2 emissions (% of total fuel combustion) in Portugal?
Provide a short and direct response. 47.05. In the year 1994, what is the difference between the CO2 emissions (% of total fuel combustion) in New Zealand and CO2 emissions (% of total fuel combustion) in Portugal?
Ensure brevity in your answer.  1.89. In the year 1995, what is the difference between the CO2 emissions (% of total fuel combustion) of Latin America(developing only) and CO2 emissions (% of total fuel combustion) of Namibia?
Offer a very short reply. -58.17. In the year 1995, what is the difference between the CO2 emissions (% of total fuel combustion) of Latin America(developing only) and CO2 emissions (% of total fuel combustion) of New Zealand?
Offer a very short reply. -1.89. In the year 1995, what is the difference between the CO2 emissions (% of total fuel combustion) in Latin America(developing only) and CO2 emissions (% of total fuel combustion) in Portugal?
Give a very brief answer. 0.44. In the year 1995, what is the difference between the CO2 emissions (% of total fuel combustion) of Namibia and CO2 emissions (% of total fuel combustion) of New Zealand?
Ensure brevity in your answer.  56.28. In the year 1995, what is the difference between the CO2 emissions (% of total fuel combustion) in Namibia and CO2 emissions (% of total fuel combustion) in Portugal?
Offer a very short reply. 58.62. In the year 1995, what is the difference between the CO2 emissions (% of total fuel combustion) in New Zealand and CO2 emissions (% of total fuel combustion) in Portugal?
Make the answer very short. 2.34. In the year 1996, what is the difference between the CO2 emissions (% of total fuel combustion) of Latin America(developing only) and CO2 emissions (% of total fuel combustion) of Namibia?
Provide a succinct answer. -28.29. In the year 1996, what is the difference between the CO2 emissions (% of total fuel combustion) in Latin America(developing only) and CO2 emissions (% of total fuel combustion) in New Zealand?
Ensure brevity in your answer.  -1.7. In the year 1996, what is the difference between the CO2 emissions (% of total fuel combustion) of Latin America(developing only) and CO2 emissions (% of total fuel combustion) of Portugal?
Make the answer very short. -1.61. In the year 1996, what is the difference between the CO2 emissions (% of total fuel combustion) in Namibia and CO2 emissions (% of total fuel combustion) in New Zealand?
Your answer should be compact. 26.59. In the year 1996, what is the difference between the CO2 emissions (% of total fuel combustion) in Namibia and CO2 emissions (% of total fuel combustion) in Portugal?
Ensure brevity in your answer.  26.68. In the year 1996, what is the difference between the CO2 emissions (% of total fuel combustion) in New Zealand and CO2 emissions (% of total fuel combustion) in Portugal?
Keep it short and to the point. 0.09. In the year 1997, what is the difference between the CO2 emissions (% of total fuel combustion) of Latin America(developing only) and CO2 emissions (% of total fuel combustion) of Namibia?
Your response must be concise. -28.56. In the year 1997, what is the difference between the CO2 emissions (% of total fuel combustion) in Latin America(developing only) and CO2 emissions (% of total fuel combustion) in New Zealand?
Provide a short and direct response. -1.55. In the year 1997, what is the difference between the CO2 emissions (% of total fuel combustion) of Latin America(developing only) and CO2 emissions (% of total fuel combustion) of Portugal?
Keep it short and to the point. -0.46. In the year 1997, what is the difference between the CO2 emissions (% of total fuel combustion) of Namibia and CO2 emissions (% of total fuel combustion) of New Zealand?
Your answer should be compact. 27.01. In the year 1997, what is the difference between the CO2 emissions (% of total fuel combustion) of Namibia and CO2 emissions (% of total fuel combustion) of Portugal?
Your answer should be very brief. 28.1. In the year 1997, what is the difference between the CO2 emissions (% of total fuel combustion) in New Zealand and CO2 emissions (% of total fuel combustion) in Portugal?
Your answer should be very brief. 1.09. In the year 1998, what is the difference between the CO2 emissions (% of total fuel combustion) in Latin America(developing only) and CO2 emissions (% of total fuel combustion) in Namibia?
Your answer should be very brief. -29.25. In the year 1998, what is the difference between the CO2 emissions (% of total fuel combustion) in Latin America(developing only) and CO2 emissions (% of total fuel combustion) in New Zealand?
Keep it short and to the point. -2.31. In the year 1998, what is the difference between the CO2 emissions (% of total fuel combustion) of Latin America(developing only) and CO2 emissions (% of total fuel combustion) of Portugal?
Provide a short and direct response. -0.31. In the year 1998, what is the difference between the CO2 emissions (% of total fuel combustion) of Namibia and CO2 emissions (% of total fuel combustion) of New Zealand?
Give a very brief answer. 26.95. In the year 1998, what is the difference between the CO2 emissions (% of total fuel combustion) of Namibia and CO2 emissions (% of total fuel combustion) of Portugal?
Give a very brief answer. 28.94. In the year 1998, what is the difference between the CO2 emissions (% of total fuel combustion) in New Zealand and CO2 emissions (% of total fuel combustion) in Portugal?
Give a very brief answer. 1.99. What is the ratio of the CO2 emissions (% of total fuel combustion) in Latin America(developing only) in 1992 to that in 1993?
Your answer should be very brief. 0.97. What is the ratio of the CO2 emissions (% of total fuel combustion) in Namibia in 1992 to that in 1993?
Provide a short and direct response. 1.18. What is the ratio of the CO2 emissions (% of total fuel combustion) of New Zealand in 1992 to that in 1993?
Keep it short and to the point. 0.98. What is the ratio of the CO2 emissions (% of total fuel combustion) in Portugal in 1992 to that in 1993?
Your response must be concise. 0.99. What is the ratio of the CO2 emissions (% of total fuel combustion) of Latin America(developing only) in 1992 to that in 1994?
Your answer should be compact. 0.89. What is the ratio of the CO2 emissions (% of total fuel combustion) in Namibia in 1992 to that in 1994?
Keep it short and to the point. 1.09. What is the ratio of the CO2 emissions (% of total fuel combustion) in New Zealand in 1992 to that in 1994?
Offer a very short reply. 0.94. What is the ratio of the CO2 emissions (% of total fuel combustion) in Portugal in 1992 to that in 1994?
Your answer should be very brief. 1.02. What is the ratio of the CO2 emissions (% of total fuel combustion) in Latin America(developing only) in 1992 to that in 1995?
Ensure brevity in your answer.  0.97. What is the ratio of the CO2 emissions (% of total fuel combustion) of Namibia in 1992 to that in 1995?
Keep it short and to the point. 0.89. What is the ratio of the CO2 emissions (% of total fuel combustion) in New Zealand in 1992 to that in 1995?
Give a very brief answer. 0.92. What is the ratio of the CO2 emissions (% of total fuel combustion) of Portugal in 1992 to that in 1995?
Make the answer very short. 1.12. What is the ratio of the CO2 emissions (% of total fuel combustion) of Latin America(developing only) in 1992 to that in 1996?
Provide a short and direct response. 0.95. What is the ratio of the CO2 emissions (% of total fuel combustion) in Namibia in 1992 to that in 1996?
Ensure brevity in your answer.  1.73. What is the ratio of the CO2 emissions (% of total fuel combustion) of New Zealand in 1992 to that in 1996?
Make the answer very short. 0.94. What is the ratio of the CO2 emissions (% of total fuel combustion) of Portugal in 1992 to that in 1996?
Ensure brevity in your answer.  0.65. What is the ratio of the CO2 emissions (% of total fuel combustion) of Latin America(developing only) in 1992 to that in 1997?
Provide a succinct answer. 0.92. What is the ratio of the CO2 emissions (% of total fuel combustion) of Namibia in 1992 to that in 1997?
Give a very brief answer. 1.71. What is the ratio of the CO2 emissions (% of total fuel combustion) of New Zealand in 1992 to that in 1997?
Make the answer very short. 0.95. What is the ratio of the CO2 emissions (% of total fuel combustion) of Portugal in 1992 to that in 1997?
Your answer should be compact. 0.82. What is the ratio of the CO2 emissions (% of total fuel combustion) in Latin America(developing only) in 1992 to that in 1998?
Provide a short and direct response. 1.07. What is the ratio of the CO2 emissions (% of total fuel combustion) in Namibia in 1992 to that in 1998?
Your answer should be compact. 1.7. What is the ratio of the CO2 emissions (% of total fuel combustion) of New Zealand in 1992 to that in 1998?
Offer a very short reply. 0.9. What is the ratio of the CO2 emissions (% of total fuel combustion) in Portugal in 1992 to that in 1998?
Your response must be concise. 0.98. What is the ratio of the CO2 emissions (% of total fuel combustion) of Latin America(developing only) in 1993 to that in 1994?
Provide a succinct answer. 0.92. What is the ratio of the CO2 emissions (% of total fuel combustion) of Namibia in 1993 to that in 1994?
Ensure brevity in your answer.  0.92. What is the ratio of the CO2 emissions (% of total fuel combustion) of New Zealand in 1993 to that in 1994?
Your answer should be compact. 0.97. What is the ratio of the CO2 emissions (% of total fuel combustion) in Portugal in 1993 to that in 1994?
Offer a terse response. 1.02. What is the ratio of the CO2 emissions (% of total fuel combustion) of Namibia in 1993 to that in 1995?
Offer a terse response. 0.75. What is the ratio of the CO2 emissions (% of total fuel combustion) of New Zealand in 1993 to that in 1995?
Provide a short and direct response. 0.94. What is the ratio of the CO2 emissions (% of total fuel combustion) of Portugal in 1993 to that in 1995?
Keep it short and to the point. 1.13. What is the ratio of the CO2 emissions (% of total fuel combustion) in Latin America(developing only) in 1993 to that in 1996?
Make the answer very short. 0.98. What is the ratio of the CO2 emissions (% of total fuel combustion) in Namibia in 1993 to that in 1996?
Make the answer very short. 1.46. What is the ratio of the CO2 emissions (% of total fuel combustion) of New Zealand in 1993 to that in 1996?
Offer a terse response. 0.96. What is the ratio of the CO2 emissions (% of total fuel combustion) in Portugal in 1993 to that in 1996?
Provide a short and direct response. 0.66. What is the ratio of the CO2 emissions (% of total fuel combustion) of Latin America(developing only) in 1993 to that in 1997?
Provide a short and direct response. 0.95. What is the ratio of the CO2 emissions (% of total fuel combustion) in Namibia in 1993 to that in 1997?
Ensure brevity in your answer.  1.45. What is the ratio of the CO2 emissions (% of total fuel combustion) in New Zealand in 1993 to that in 1997?
Give a very brief answer. 0.97. What is the ratio of the CO2 emissions (% of total fuel combustion) of Portugal in 1993 to that in 1997?
Your response must be concise. 0.83. What is the ratio of the CO2 emissions (% of total fuel combustion) of Latin America(developing only) in 1993 to that in 1998?
Keep it short and to the point. 1.11. What is the ratio of the CO2 emissions (% of total fuel combustion) of Namibia in 1993 to that in 1998?
Your answer should be compact. 1.44. What is the ratio of the CO2 emissions (% of total fuel combustion) of New Zealand in 1993 to that in 1998?
Your answer should be compact. 0.92. What is the ratio of the CO2 emissions (% of total fuel combustion) of Portugal in 1993 to that in 1998?
Ensure brevity in your answer.  0.98. What is the ratio of the CO2 emissions (% of total fuel combustion) of Namibia in 1994 to that in 1995?
Keep it short and to the point. 0.82. What is the ratio of the CO2 emissions (% of total fuel combustion) in New Zealand in 1994 to that in 1995?
Provide a succinct answer. 0.97. What is the ratio of the CO2 emissions (% of total fuel combustion) of Portugal in 1994 to that in 1995?
Provide a short and direct response. 1.1. What is the ratio of the CO2 emissions (% of total fuel combustion) of Latin America(developing only) in 1994 to that in 1996?
Make the answer very short. 1.06. What is the ratio of the CO2 emissions (% of total fuel combustion) in Namibia in 1994 to that in 1996?
Your response must be concise. 1.58. What is the ratio of the CO2 emissions (% of total fuel combustion) of Portugal in 1994 to that in 1996?
Ensure brevity in your answer.  0.64. What is the ratio of the CO2 emissions (% of total fuel combustion) in Latin America(developing only) in 1994 to that in 1997?
Offer a very short reply. 1.03. What is the ratio of the CO2 emissions (% of total fuel combustion) in Namibia in 1994 to that in 1997?
Make the answer very short. 1.57. What is the ratio of the CO2 emissions (% of total fuel combustion) in Portugal in 1994 to that in 1997?
Give a very brief answer. 0.81. What is the ratio of the CO2 emissions (% of total fuel combustion) of Latin America(developing only) in 1994 to that in 1998?
Provide a succinct answer. 1.2. What is the ratio of the CO2 emissions (% of total fuel combustion) of Namibia in 1994 to that in 1998?
Provide a succinct answer. 1.56. What is the ratio of the CO2 emissions (% of total fuel combustion) of New Zealand in 1994 to that in 1998?
Your answer should be very brief. 0.96. What is the ratio of the CO2 emissions (% of total fuel combustion) of Portugal in 1994 to that in 1998?
Offer a very short reply. 0.96. What is the ratio of the CO2 emissions (% of total fuel combustion) in Latin America(developing only) in 1995 to that in 1996?
Offer a terse response. 0.98. What is the ratio of the CO2 emissions (% of total fuel combustion) in Namibia in 1995 to that in 1996?
Offer a terse response. 1.94. What is the ratio of the CO2 emissions (% of total fuel combustion) in New Zealand in 1995 to that in 1996?
Offer a very short reply. 1.02. What is the ratio of the CO2 emissions (% of total fuel combustion) in Portugal in 1995 to that in 1996?
Offer a very short reply. 0.58. What is the ratio of the CO2 emissions (% of total fuel combustion) of Latin America(developing only) in 1995 to that in 1997?
Provide a short and direct response. 0.95. What is the ratio of the CO2 emissions (% of total fuel combustion) of Namibia in 1995 to that in 1997?
Offer a very short reply. 1.92. What is the ratio of the CO2 emissions (% of total fuel combustion) in New Zealand in 1995 to that in 1997?
Ensure brevity in your answer.  1.03. What is the ratio of the CO2 emissions (% of total fuel combustion) in Portugal in 1995 to that in 1997?
Your answer should be very brief. 0.73. What is the ratio of the CO2 emissions (% of total fuel combustion) of Latin America(developing only) in 1995 to that in 1998?
Ensure brevity in your answer.  1.11. What is the ratio of the CO2 emissions (% of total fuel combustion) in Namibia in 1995 to that in 1998?
Give a very brief answer. 1.9. What is the ratio of the CO2 emissions (% of total fuel combustion) of New Zealand in 1995 to that in 1998?
Keep it short and to the point. 0.98. What is the ratio of the CO2 emissions (% of total fuel combustion) in Portugal in 1995 to that in 1998?
Keep it short and to the point. 0.87. What is the ratio of the CO2 emissions (% of total fuel combustion) in Latin America(developing only) in 1996 to that in 1997?
Your response must be concise. 0.97. What is the ratio of the CO2 emissions (% of total fuel combustion) in Namibia in 1996 to that in 1997?
Keep it short and to the point. 0.99. What is the ratio of the CO2 emissions (% of total fuel combustion) of New Zealand in 1996 to that in 1997?
Your answer should be very brief. 1.01. What is the ratio of the CO2 emissions (% of total fuel combustion) of Portugal in 1996 to that in 1997?
Give a very brief answer. 1.26. What is the ratio of the CO2 emissions (% of total fuel combustion) of Latin America(developing only) in 1996 to that in 1998?
Your answer should be compact. 1.13. What is the ratio of the CO2 emissions (% of total fuel combustion) in Namibia in 1996 to that in 1998?
Offer a very short reply. 0.98. What is the ratio of the CO2 emissions (% of total fuel combustion) of New Zealand in 1996 to that in 1998?
Your answer should be very brief. 0.96. What is the ratio of the CO2 emissions (% of total fuel combustion) of Portugal in 1996 to that in 1998?
Keep it short and to the point. 1.5. What is the ratio of the CO2 emissions (% of total fuel combustion) of Latin America(developing only) in 1997 to that in 1998?
Make the answer very short. 1.16. What is the ratio of the CO2 emissions (% of total fuel combustion) in Namibia in 1997 to that in 1998?
Give a very brief answer. 0.99. What is the ratio of the CO2 emissions (% of total fuel combustion) in New Zealand in 1997 to that in 1998?
Provide a succinct answer. 0.95. What is the ratio of the CO2 emissions (% of total fuel combustion) of Portugal in 1997 to that in 1998?
Offer a terse response. 1.19. What is the difference between the highest and the second highest CO2 emissions (% of total fuel combustion) of Latin America(developing only)?
Provide a short and direct response. 0.11. What is the difference between the highest and the second highest CO2 emissions (% of total fuel combustion) in Namibia?
Offer a very short reply. 6.66. What is the difference between the highest and the second highest CO2 emissions (% of total fuel combustion) of New Zealand?
Make the answer very short. 0.09. What is the difference between the highest and the second highest CO2 emissions (% of total fuel combustion) in Portugal?
Give a very brief answer. 1.04. What is the difference between the highest and the lowest CO2 emissions (% of total fuel combustion) of Latin America(developing only)?
Offer a very short reply. 0.61. What is the difference between the highest and the lowest CO2 emissions (% of total fuel combustion) of Namibia?
Keep it short and to the point. 29.81. What is the difference between the highest and the lowest CO2 emissions (% of total fuel combustion) of New Zealand?
Offer a very short reply. 0.53. What is the difference between the highest and the lowest CO2 emissions (% of total fuel combustion) of Portugal?
Your answer should be very brief. 2.12. 